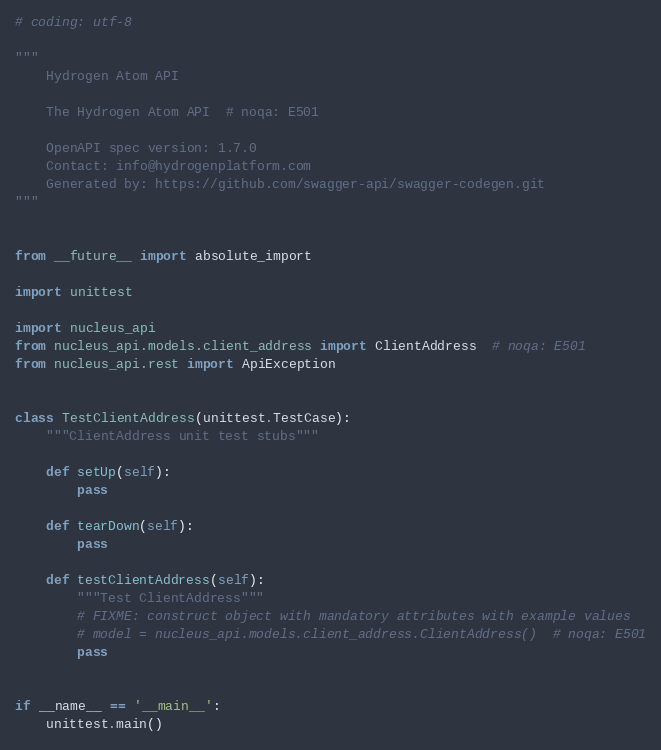<code> <loc_0><loc_0><loc_500><loc_500><_Python_># coding: utf-8

"""
    Hydrogen Atom API

    The Hydrogen Atom API  # noqa: E501

    OpenAPI spec version: 1.7.0
    Contact: info@hydrogenplatform.com
    Generated by: https://github.com/swagger-api/swagger-codegen.git
"""


from __future__ import absolute_import

import unittest

import nucleus_api
from nucleus_api.models.client_address import ClientAddress  # noqa: E501
from nucleus_api.rest import ApiException


class TestClientAddress(unittest.TestCase):
    """ClientAddress unit test stubs"""

    def setUp(self):
        pass

    def tearDown(self):
        pass

    def testClientAddress(self):
        """Test ClientAddress"""
        # FIXME: construct object with mandatory attributes with example values
        # model = nucleus_api.models.client_address.ClientAddress()  # noqa: E501
        pass


if __name__ == '__main__':
    unittest.main()
</code> 